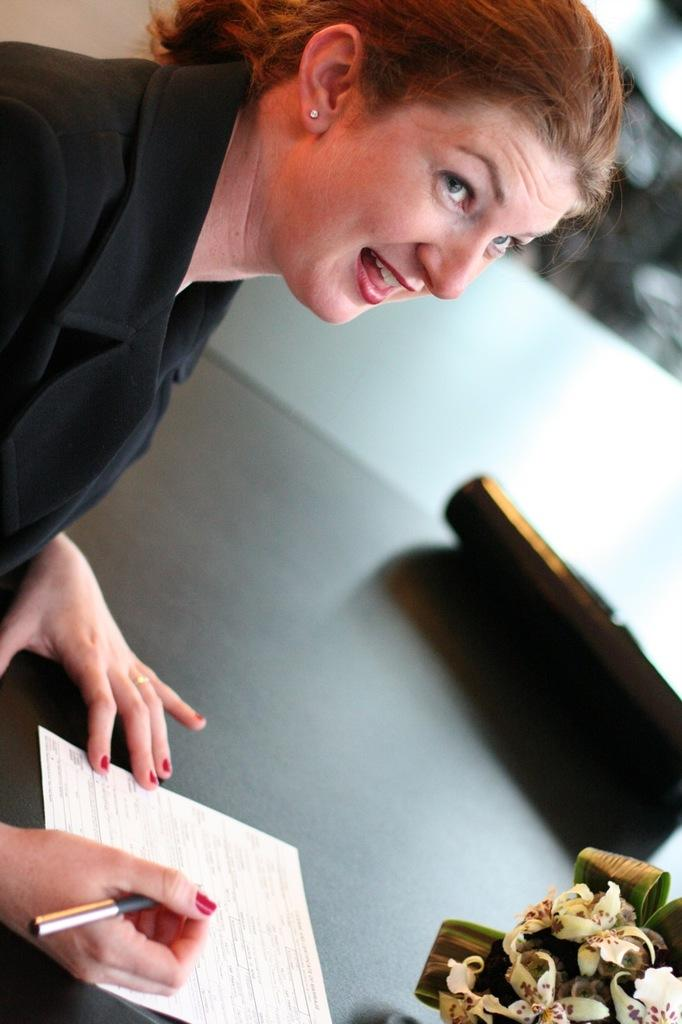Who is present in the image? There is a woman in the image. What is the woman holding in her hand? The woman is holding a pen. What can be seen on the table in the image? There is paper visible in the image, and there is an object on the table. What type of decorative elements are present in the image? There are flowers in the image. How would you describe the background of the image? The background of the image is blurry. What type of fork can be seen in the woman's hand in the image? There is no fork present in the image; the woman is holding a pen. Can you describe the hydrant that is visible in the background of the image? There is no hydrant present in the image; the background is blurry. 